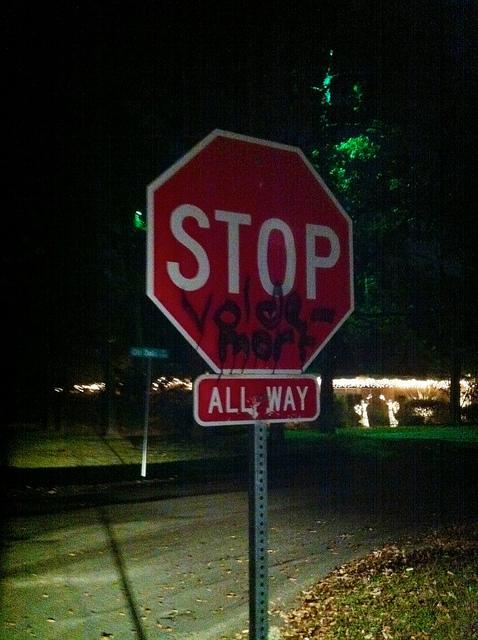What does the sign say?
Quick response, please. Stop. Which directions must stop?
Give a very brief answer. All. Is there construction nearby?
Give a very brief answer. No. What is the color of the letters?
Quick response, please. White. What book is referenced by the graffiti?
Concise answer only. Harry potter. Is it night time?
Give a very brief answer. Yes. 